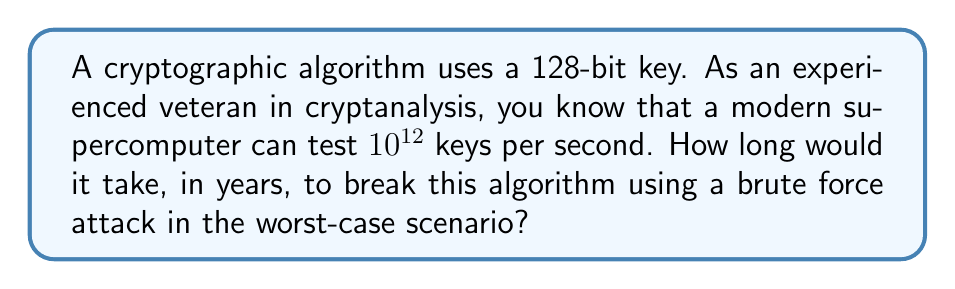What is the answer to this math problem? Let's approach this step-by-step:

1) First, we need to calculate the total number of possible keys:
   With a 128-bit key, there are $2^{128}$ possible combinations.

2) Now, let's convert the computer's speed to keys per year:
   Keys per year = $10^{12}$ keys/second * 60 seconds/minute * 60 minutes/hour * 24 hours/day * 365.25 days/year
   $$ \text{Keys per year} = 10^{12} * 60 * 60 * 24 * 365.25 = 3.1557 * 10^{19} $$

3) In the worst-case scenario, we might need to test all possible keys. So, we divide the total number of keys by the number of keys that can be tested per year:

   $$ \text{Years} = \frac{2^{128}}{3.1557 * 10^{19}} $$

4) Let's calculate this:
   $$ 2^{128} \approx 3.4028 * 10^{38} $$
   
   $$ \text{Years} = \frac{3.4028 * 10^{38}}{3.1557 * 10^{19}} \approx 1.0783 * 10^{19} $$

5) This is approximately 10.783 quintillion years.
Answer: $1.0783 * 10^{19}$ years 